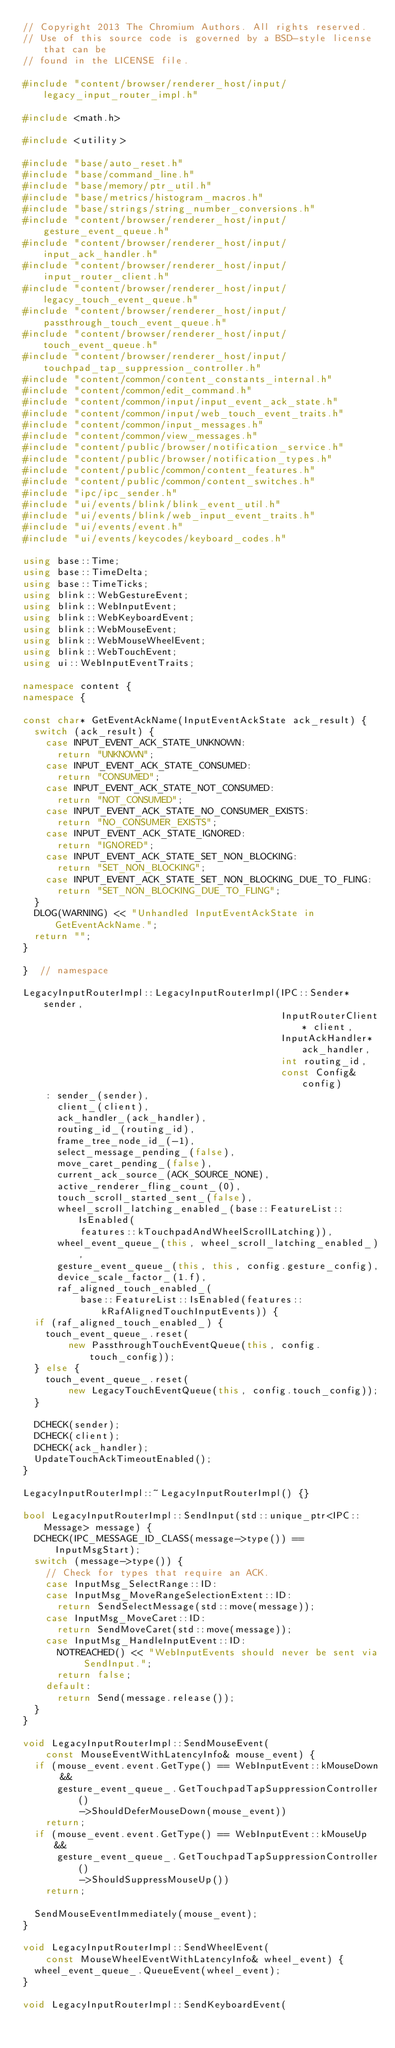Convert code to text. <code><loc_0><loc_0><loc_500><loc_500><_C++_>// Copyright 2013 The Chromium Authors. All rights reserved.
// Use of this source code is governed by a BSD-style license that can be
// found in the LICENSE file.

#include "content/browser/renderer_host/input/legacy_input_router_impl.h"

#include <math.h>

#include <utility>

#include "base/auto_reset.h"
#include "base/command_line.h"
#include "base/memory/ptr_util.h"
#include "base/metrics/histogram_macros.h"
#include "base/strings/string_number_conversions.h"
#include "content/browser/renderer_host/input/gesture_event_queue.h"
#include "content/browser/renderer_host/input/input_ack_handler.h"
#include "content/browser/renderer_host/input/input_router_client.h"
#include "content/browser/renderer_host/input/legacy_touch_event_queue.h"
#include "content/browser/renderer_host/input/passthrough_touch_event_queue.h"
#include "content/browser/renderer_host/input/touch_event_queue.h"
#include "content/browser/renderer_host/input/touchpad_tap_suppression_controller.h"
#include "content/common/content_constants_internal.h"
#include "content/common/edit_command.h"
#include "content/common/input/input_event_ack_state.h"
#include "content/common/input/web_touch_event_traits.h"
#include "content/common/input_messages.h"
#include "content/common/view_messages.h"
#include "content/public/browser/notification_service.h"
#include "content/public/browser/notification_types.h"
#include "content/public/common/content_features.h"
#include "content/public/common/content_switches.h"
#include "ipc/ipc_sender.h"
#include "ui/events/blink/blink_event_util.h"
#include "ui/events/blink/web_input_event_traits.h"
#include "ui/events/event.h"
#include "ui/events/keycodes/keyboard_codes.h"

using base::Time;
using base::TimeDelta;
using base::TimeTicks;
using blink::WebGestureEvent;
using blink::WebInputEvent;
using blink::WebKeyboardEvent;
using blink::WebMouseEvent;
using blink::WebMouseWheelEvent;
using blink::WebTouchEvent;
using ui::WebInputEventTraits;

namespace content {
namespace {

const char* GetEventAckName(InputEventAckState ack_result) {
  switch (ack_result) {
    case INPUT_EVENT_ACK_STATE_UNKNOWN:
      return "UNKNOWN";
    case INPUT_EVENT_ACK_STATE_CONSUMED:
      return "CONSUMED";
    case INPUT_EVENT_ACK_STATE_NOT_CONSUMED:
      return "NOT_CONSUMED";
    case INPUT_EVENT_ACK_STATE_NO_CONSUMER_EXISTS:
      return "NO_CONSUMER_EXISTS";
    case INPUT_EVENT_ACK_STATE_IGNORED:
      return "IGNORED";
    case INPUT_EVENT_ACK_STATE_SET_NON_BLOCKING:
      return "SET_NON_BLOCKING";
    case INPUT_EVENT_ACK_STATE_SET_NON_BLOCKING_DUE_TO_FLING:
      return "SET_NON_BLOCKING_DUE_TO_FLING";
  }
  DLOG(WARNING) << "Unhandled InputEventAckState in GetEventAckName.";
  return "";
}

}  // namespace

LegacyInputRouterImpl::LegacyInputRouterImpl(IPC::Sender* sender,
                                             InputRouterClient* client,
                                             InputAckHandler* ack_handler,
                                             int routing_id,
                                             const Config& config)
    : sender_(sender),
      client_(client),
      ack_handler_(ack_handler),
      routing_id_(routing_id),
      frame_tree_node_id_(-1),
      select_message_pending_(false),
      move_caret_pending_(false),
      current_ack_source_(ACK_SOURCE_NONE),
      active_renderer_fling_count_(0),
      touch_scroll_started_sent_(false),
      wheel_scroll_latching_enabled_(base::FeatureList::IsEnabled(
          features::kTouchpadAndWheelScrollLatching)),
      wheel_event_queue_(this, wheel_scroll_latching_enabled_),
      gesture_event_queue_(this, this, config.gesture_config),
      device_scale_factor_(1.f),
      raf_aligned_touch_enabled_(
          base::FeatureList::IsEnabled(features::kRafAlignedTouchInputEvents)) {
  if (raf_aligned_touch_enabled_) {
    touch_event_queue_.reset(
        new PassthroughTouchEventQueue(this, config.touch_config));
  } else {
    touch_event_queue_.reset(
        new LegacyTouchEventQueue(this, config.touch_config));
  }

  DCHECK(sender);
  DCHECK(client);
  DCHECK(ack_handler);
  UpdateTouchAckTimeoutEnabled();
}

LegacyInputRouterImpl::~LegacyInputRouterImpl() {}

bool LegacyInputRouterImpl::SendInput(std::unique_ptr<IPC::Message> message) {
  DCHECK(IPC_MESSAGE_ID_CLASS(message->type()) == InputMsgStart);
  switch (message->type()) {
    // Check for types that require an ACK.
    case InputMsg_SelectRange::ID:
    case InputMsg_MoveRangeSelectionExtent::ID:
      return SendSelectMessage(std::move(message));
    case InputMsg_MoveCaret::ID:
      return SendMoveCaret(std::move(message));
    case InputMsg_HandleInputEvent::ID:
      NOTREACHED() << "WebInputEvents should never be sent via SendInput.";
      return false;
    default:
      return Send(message.release());
  }
}

void LegacyInputRouterImpl::SendMouseEvent(
    const MouseEventWithLatencyInfo& mouse_event) {
  if (mouse_event.event.GetType() == WebInputEvent::kMouseDown &&
      gesture_event_queue_.GetTouchpadTapSuppressionController()
          ->ShouldDeferMouseDown(mouse_event))
    return;
  if (mouse_event.event.GetType() == WebInputEvent::kMouseUp &&
      gesture_event_queue_.GetTouchpadTapSuppressionController()
          ->ShouldSuppressMouseUp())
    return;

  SendMouseEventImmediately(mouse_event);
}

void LegacyInputRouterImpl::SendWheelEvent(
    const MouseWheelEventWithLatencyInfo& wheel_event) {
  wheel_event_queue_.QueueEvent(wheel_event);
}

void LegacyInputRouterImpl::SendKeyboardEvent(</code> 